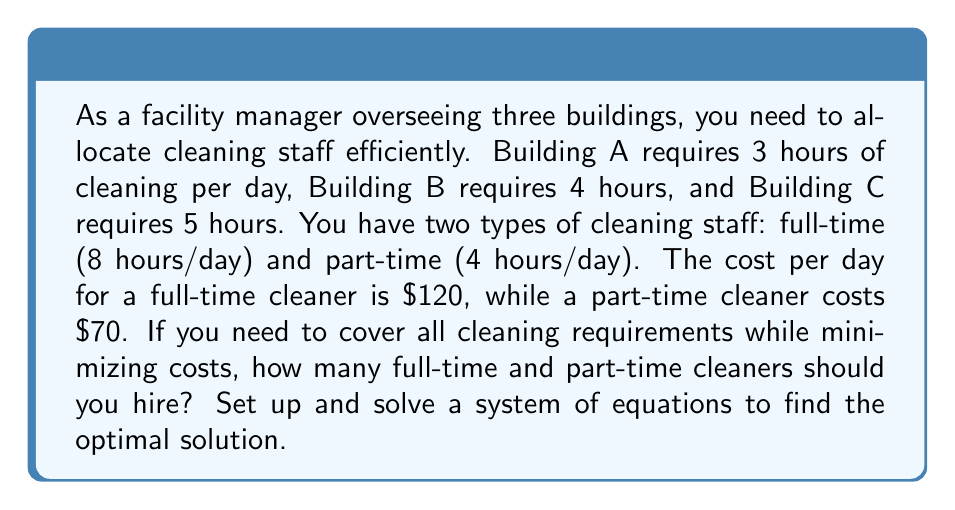Could you help me with this problem? Let's approach this step-by-step:

1) Let $x$ be the number of full-time cleaners and $y$ be the number of part-time cleaners.

2) Set up the equation for total cleaning hours:
   $$ 8x + 4y = 3 + 4 + 5 = 12 $$
   This ensures all cleaning requirements are met.

3) Set up the equation for total cost:
   $$ 120x + 70y = C $$
   Where $C$ is the total cost we want to minimize.

4) We now have a system of two equations:
   $$ \begin{cases}
   8x + 4y = 12 \\
   120x + 70y = C
   \end{cases} $$

5) From the first equation, express $y$ in terms of $x$:
   $$ y = 3 - 2x $$

6) Substitute this into the cost equation:
   $$ 120x + 70(3 - 2x) = C $$
   $$ 120x + 210 - 140x = C $$
   $$ -20x + 210 = C $$

7) To minimize $C$, we need to maximize $20x$ while ensuring $x$ and $y$ are non-negative integers.

8) The maximum value of $x$ that keeps $y$ non-negative is 1.5, but since $x$ must be an integer, the optimal solution is $x = 1$ and $y = 1$.

9) Verify:
   $$ 8(1) + 4(1) = 12 $$ (hours requirement met)
   $$ 120(1) + 70(1) = 190 $$ (minimum cost)
Answer: 1 full-time and 1 part-time cleaner 